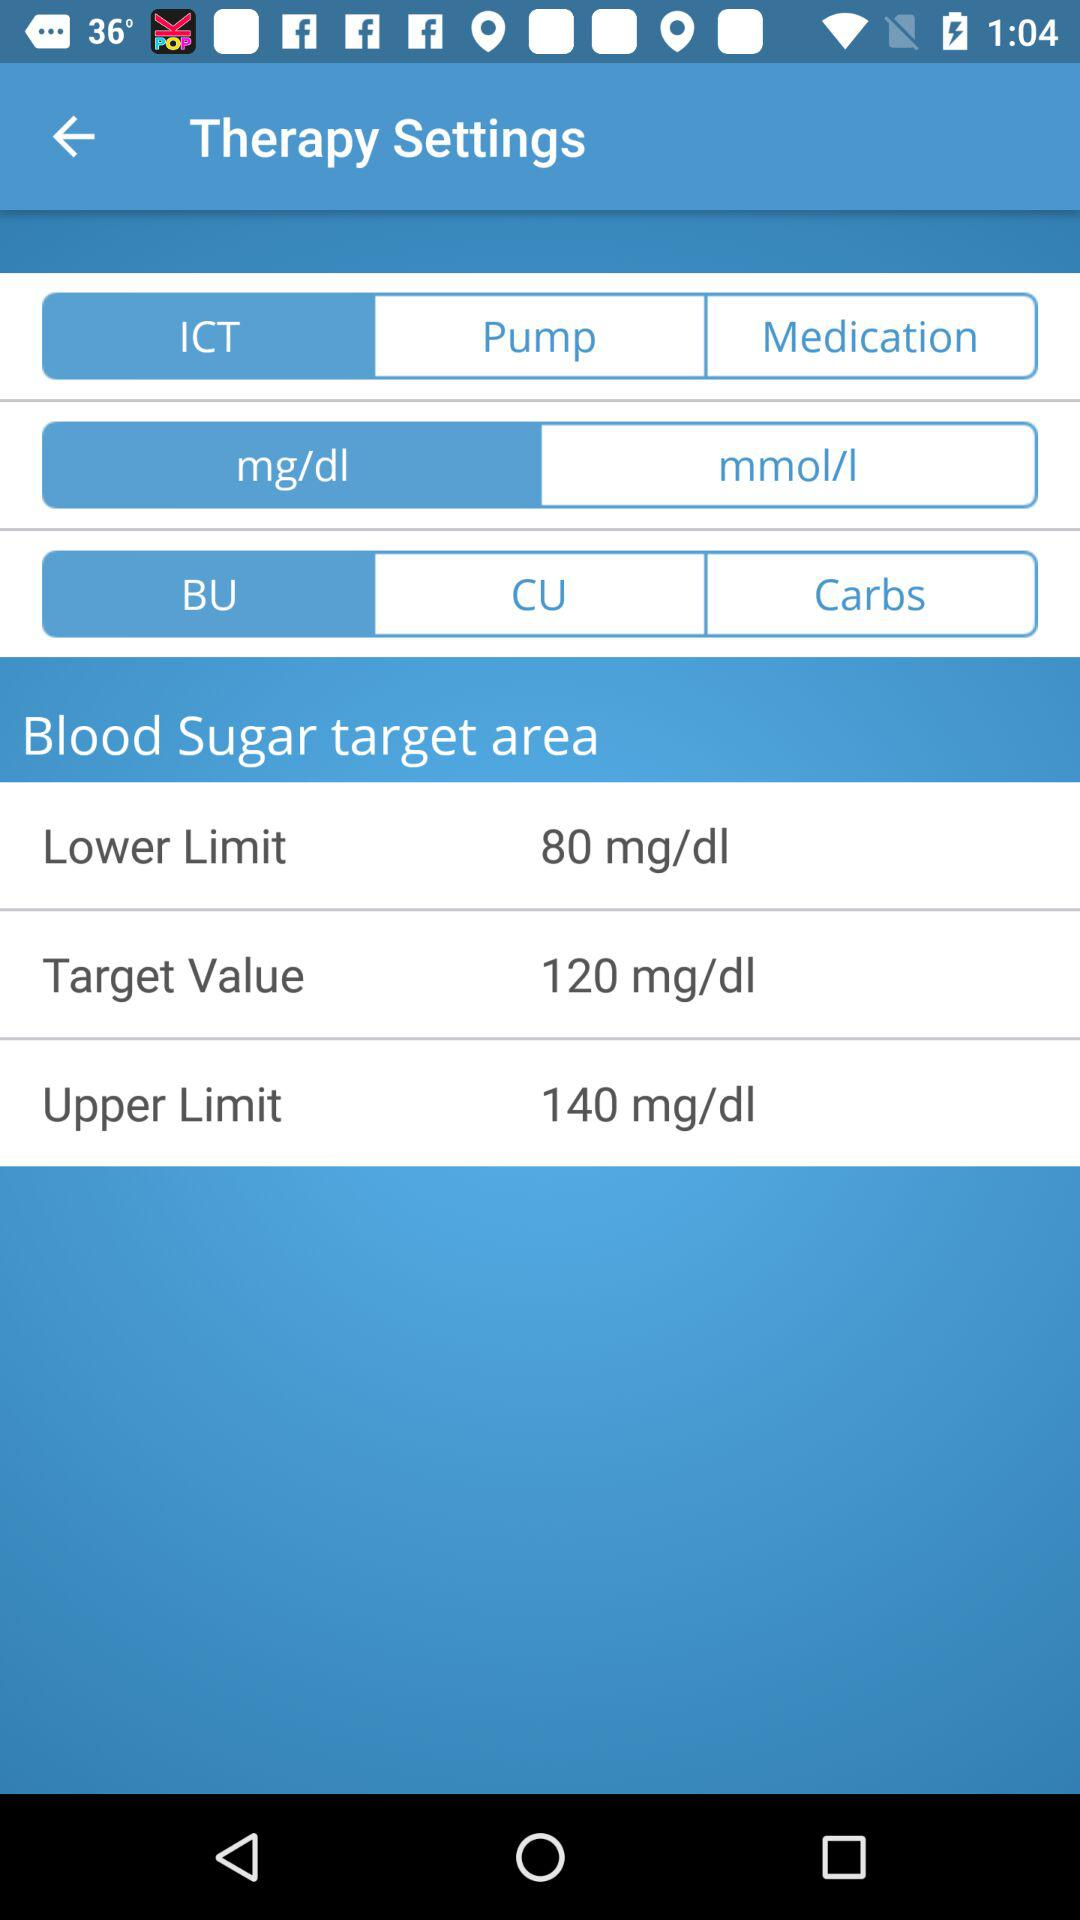What is the target value of blood sugar? The target value is 120 mg/dl. 